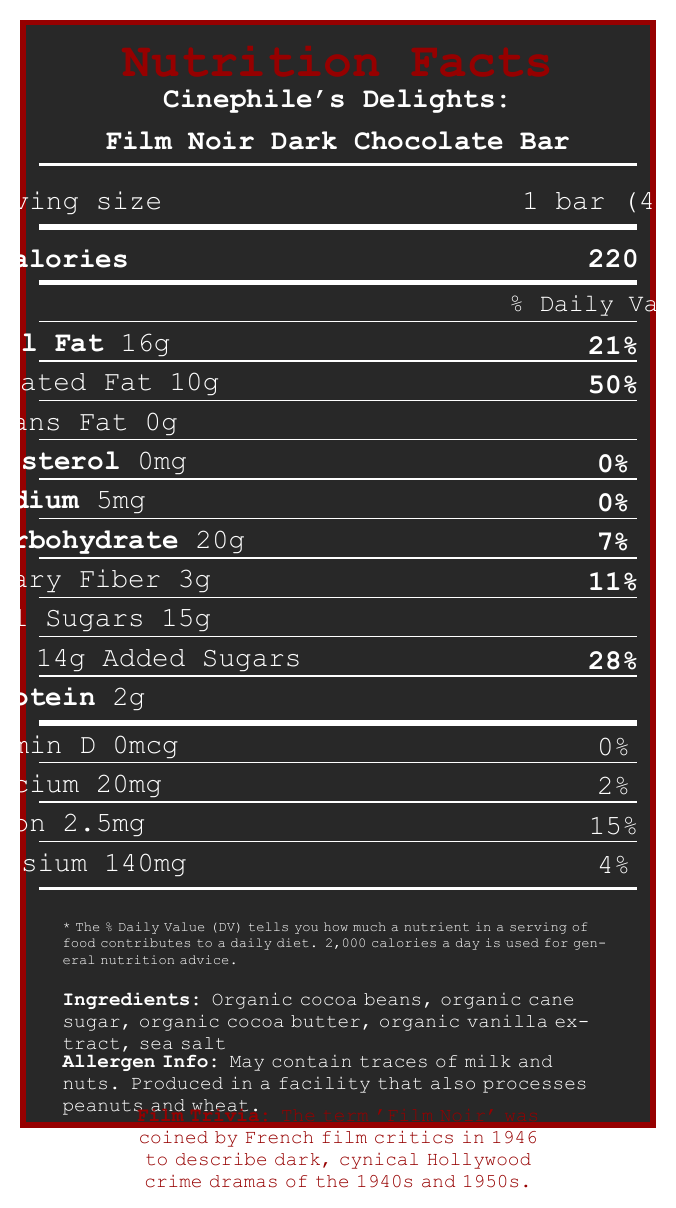what is the product name? The product name is located at the top of the document.
Answer: Cinephile's Delights: Film Noir Dark Chocolate Bar how many calories are in one serving? The document shows that one bar (serving) contains 220 calories.
Answer: 220 what percentage of the daily value of saturated fat does one serving have? The daily value percentage for saturated fat is indicated as 50%.
Answer: 50% what is the serving size? The serving size, located near the top, is listed as 1 bar (40g).
Answer: 1 bar (40g) what are the main ingredients in this chocolate bar? The ingredients are listed near the bottom of the document.
Answer: Organic cocoa beans, organic cane sugar, organic cocoa butter, organic vanilla extract, sea salt which nutrient has the lowest percentage of the daily value? A. Vitamin D B. Sodium C. Calcium D. Iron Vitamin D is shown with 0% of the daily value, which is the lowest.
Answer: A. Vitamin D how much protein is in one serving? A. 2g B. 5g C. 10g D. 1g The document mentions that one serving contains 2 grams of protein.
Answer: A. 2g does this product contain any trans fat? According to the document, the trans fat content is 0g.
Answer: No does this chocolate bar contain any dairy ingredients? The allergen info states it may contain traces of milk, but it does not confirm the presence of dairy ingredients in the actual recipe.
Answer: Not enough information summarize the entire document. The document contains comprehensive nutrition information. It also includes additional content related to the Film Noir theme, and information about sustainability, events, and pairing suggestions.
Answer: The document presents the nutrition facts for the Cinephile's Delights: Film Noir Dark Chocolate Bar, including serving size, calorie content, and nutrient breakdowns with their respective daily values. It lists the ingredients, allergen information, and some additional details like film trivia, a museum event, a sustainability note, and a pairing suggestion. The design of the document is thematic, aligning with the Film Noir genre. 